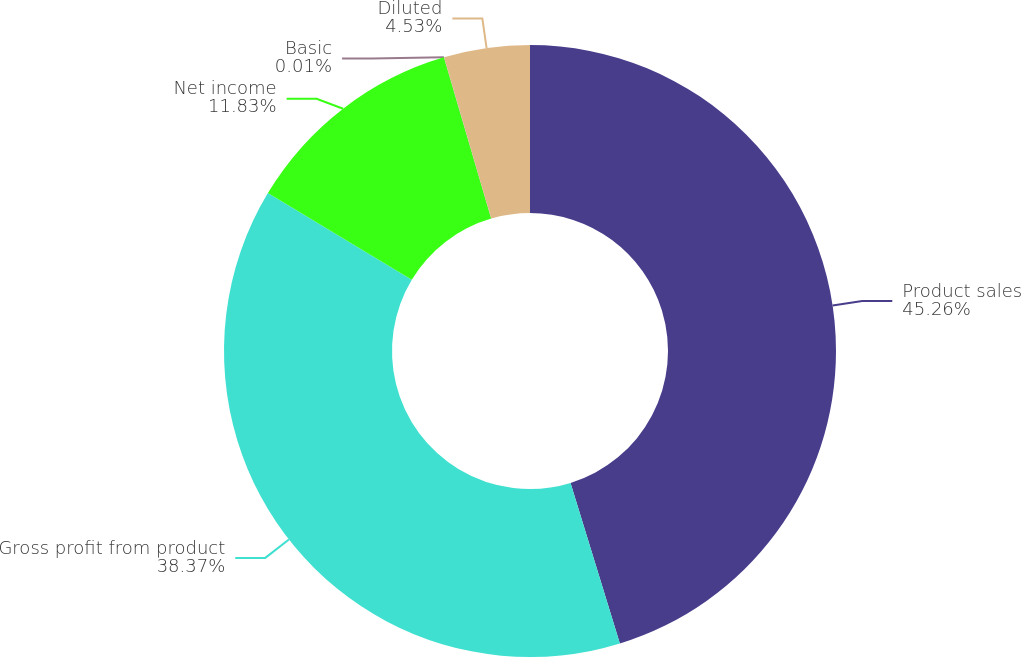Convert chart. <chart><loc_0><loc_0><loc_500><loc_500><pie_chart><fcel>Product sales<fcel>Gross profit from product<fcel>Net income<fcel>Basic<fcel>Diluted<nl><fcel>45.25%<fcel>38.37%<fcel>11.83%<fcel>0.01%<fcel>4.53%<nl></chart> 